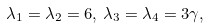<formula> <loc_0><loc_0><loc_500><loc_500>\lambda _ { 1 } = \lambda _ { 2 } = 6 , \, \lambda _ { 3 } = \lambda _ { 4 } = 3 \gamma ,</formula> 